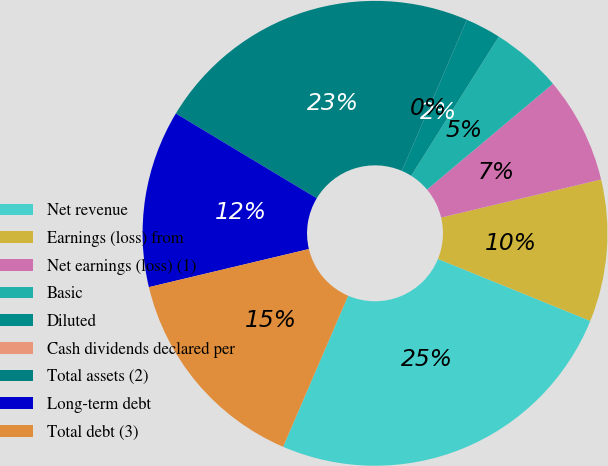<chart> <loc_0><loc_0><loc_500><loc_500><pie_chart><fcel>Net revenue<fcel>Earnings (loss) from<fcel>Net earnings (loss) (1)<fcel>Basic<fcel>Diluted<fcel>Cash dividends declared per<fcel>Total assets (2)<fcel>Long-term debt<fcel>Total debt (3)<nl><fcel>25.32%<fcel>9.87%<fcel>7.4%<fcel>4.94%<fcel>2.47%<fcel>0.0%<fcel>22.85%<fcel>12.34%<fcel>14.81%<nl></chart> 